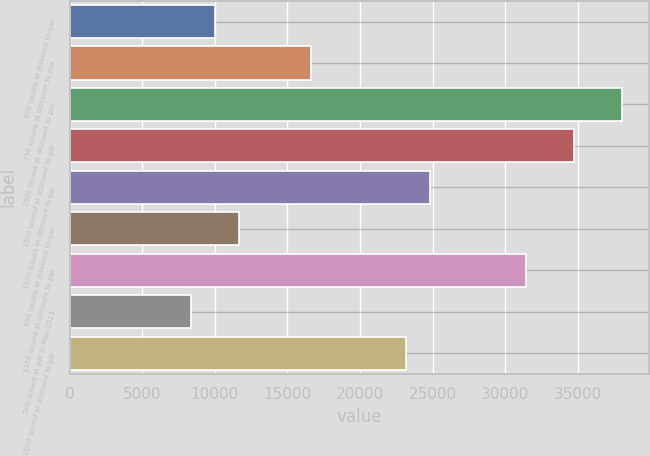<chart> <loc_0><loc_0><loc_500><loc_500><bar_chart><fcel>500 issued at discount to par<fcel>750 issued at discount to par<fcel>2000 issued at discount to par<fcel>1500 issued at discount to par<fcel>1100 issued at discount to par<fcel>650 issued at discount to par<fcel>1350 issued at discount to par<fcel>500 issued at par in May 2011<fcel>1000 issued at discount to par<nl><fcel>10023.6<fcel>16608<fcel>38007.3<fcel>34715.1<fcel>24838.5<fcel>11669.7<fcel>31422.9<fcel>8377.5<fcel>23192.4<nl></chart> 